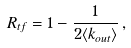<formula> <loc_0><loc_0><loc_500><loc_500>R _ { t f } = 1 - \frac { 1 } { 2 \langle k _ { o u t } \rangle } \, ,</formula> 